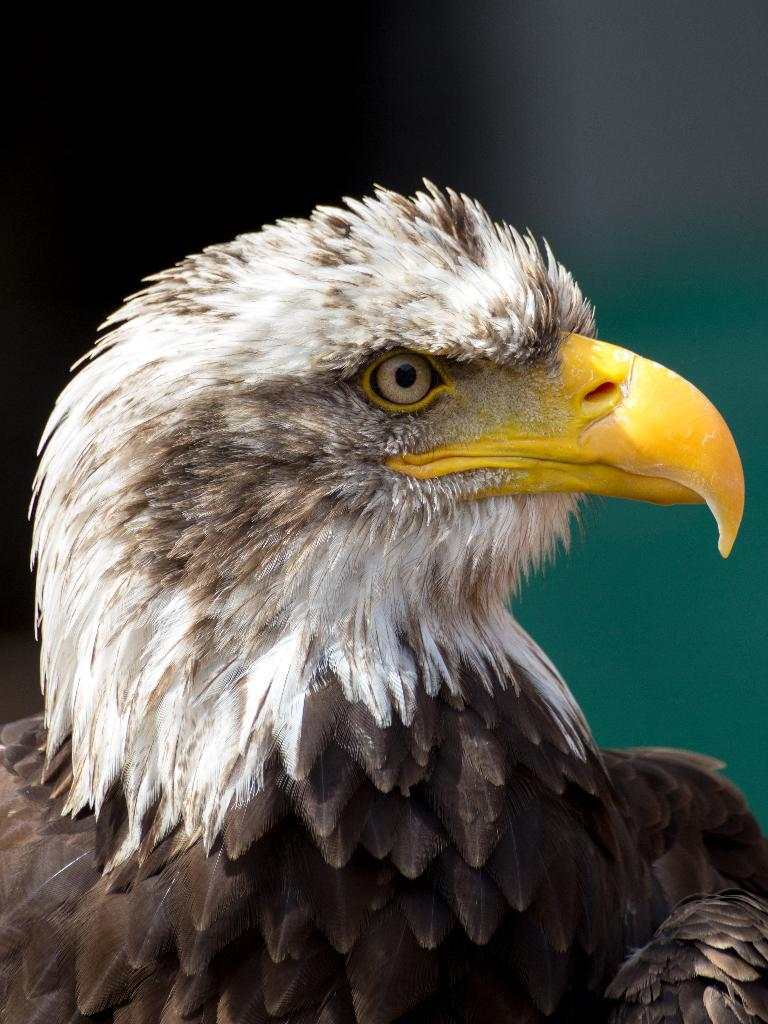What type of animal can be seen in the image? There is a bird in the image. What type of hill can be seen in the background of the image? There is no hill present in the image; it only features a bird. 